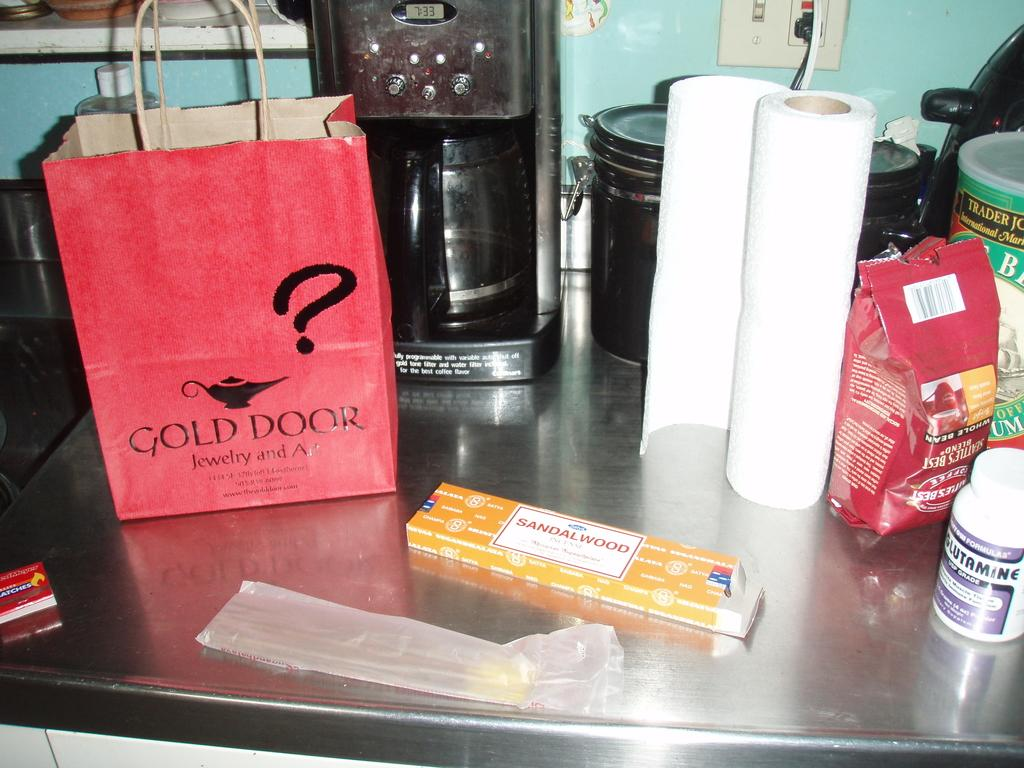<image>
Write a terse but informative summary of the picture. A paper bag from the Gold Door jewelry shop sits on a table next to some sandalwood incense sticks. 